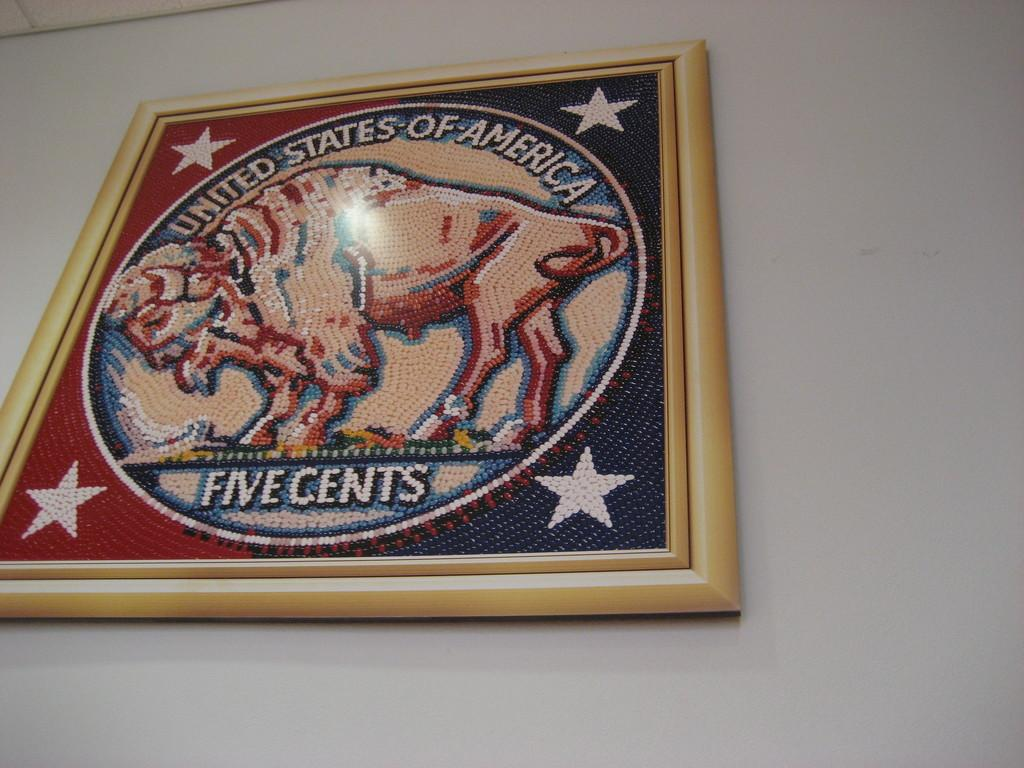What is on the wall in the image? There is a frame on the wall in the image. Can you see a river flowing through the frame in the image? No, there is no river visible in the image. The image only shows a frame on the wall. 